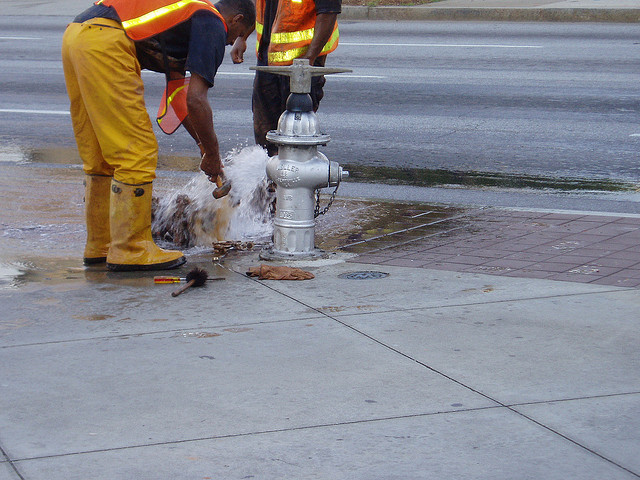<image>Where is the manhole cover on the street? It is uncertain where the manhole cover on the street is located. It might be by the hydrant or in the middle of the street. Where is the manhole cover on the street? It is uncertain where the manhole cover is on the street. It can be by the hydrant, in the middle, or on the side. 